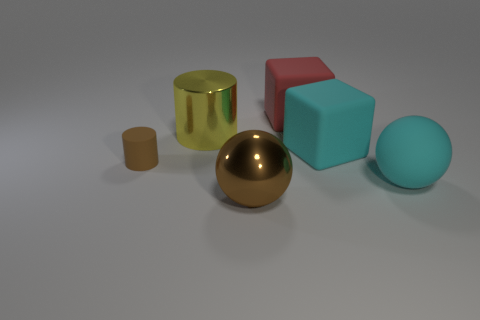Add 4 rubber blocks. How many objects exist? 10 Subtract all blocks. How many objects are left? 4 Subtract all gray rubber objects. Subtract all big yellow things. How many objects are left? 5 Add 3 big yellow cylinders. How many big yellow cylinders are left? 4 Add 4 brown shiny balls. How many brown shiny balls exist? 5 Subtract 1 red cubes. How many objects are left? 5 